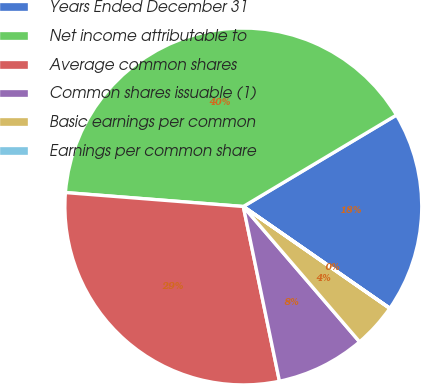Convert chart to OTSL. <chart><loc_0><loc_0><loc_500><loc_500><pie_chart><fcel>Years Ended December 31<fcel>Net income attributable to<fcel>Average common shares<fcel>Common shares issuable (1)<fcel>Basic earnings per common<fcel>Earnings per common share<nl><fcel>18.23%<fcel>40.19%<fcel>29.49%<fcel>8.05%<fcel>4.03%<fcel>0.01%<nl></chart> 